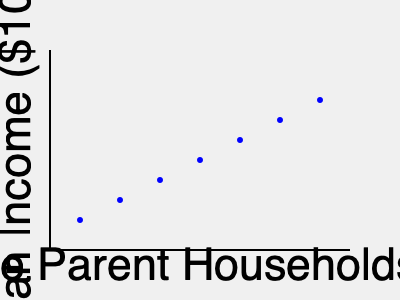Based on the scatter plot showing the relationship between the percentage of single parent households and median income, what can be inferred about the correlation between single parenthood and socioeconomic status? How might this information be relevant to advocacy efforts for single parents' rights? To analyze the correlation between single parenthood and socioeconomic status based on the scatter plot, we need to follow these steps:

1. Observe the overall trend:
   The scatter plot shows a clear downward trend from left to right.

2. Interpret the axes:
   - X-axis: Percentage of single parent households (increasing from left to right)
   - Y-axis: Median income in thousands of dollars (increasing from bottom to top)

3. Analyze the relationship:
   As the percentage of single parent households increases, the median income decreases.

4. Determine the type of correlation:
   This represents a negative (inverse) correlation between the two variables.

5. Assess the strength of the correlation:
   The points form a relatively straight line with little scatter, indicating a strong correlation.

6. Calculate the correlation coefficient:
   While we can't calculate the exact correlation coefficient without the raw data, visually, it appears to be close to -1, suggesting a strong negative correlation.

7. Consider the implications:
   - Areas with higher percentages of single parent households tend to have lower median incomes.
   - This suggests that single parenthood is associated with lower socioeconomic status.

8. Relevance to advocacy efforts:
   - This data could be used to argue for increased support for single parents, such as:
     a) Improved childcare assistance
     b) Enhanced job training programs
     c) Stronger enforcement of child support payments
     d) Targeted economic development in areas with high concentrations of single parent households

9. Limitations to consider:
   - Correlation does not imply causation; other factors may influence both variables.
   - The data doesn't account for individual circumstances or variations within communities.

10. Potential advocacy strategies:
    - Use this data to highlight the economic challenges faced by single parents.
    - Propose policies that address the specific needs of single parent families.
    - Advocate for research into the causes of this correlation and potential interventions.
Answer: Strong negative correlation between single parenthood and median income, indicating lower socioeconomic status for single parent households; useful for advocating increased support and targeted interventions. 